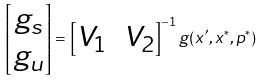Convert formula to latex. <formula><loc_0><loc_0><loc_500><loc_500>\begin{bmatrix} g _ { s } \\ g _ { u } \end{bmatrix} = \begin{bmatrix} V _ { 1 } & V _ { 2 } \end{bmatrix} ^ { - 1 } g ( x ^ { \prime } , x ^ { * } , p ^ { * } )</formula> 